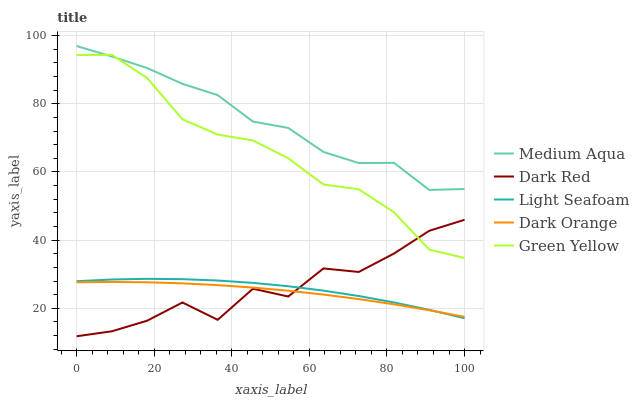Does Green Yellow have the minimum area under the curve?
Answer yes or no. No. Does Green Yellow have the maximum area under the curve?
Answer yes or no. No. Is Green Yellow the smoothest?
Answer yes or no. No. Is Green Yellow the roughest?
Answer yes or no. No. Does Green Yellow have the lowest value?
Answer yes or no. No. Does Green Yellow have the highest value?
Answer yes or no. No. Is Light Seafoam less than Green Yellow?
Answer yes or no. Yes. Is Medium Aqua greater than Light Seafoam?
Answer yes or no. Yes. Does Light Seafoam intersect Green Yellow?
Answer yes or no. No. 